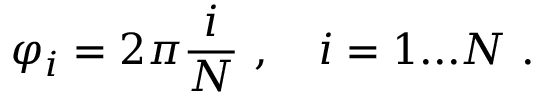<formula> <loc_0><loc_0><loc_500><loc_500>\varphi _ { i } = 2 \pi \frac { i } { N } \ , \quad i = 1 \dots N \ .</formula> 